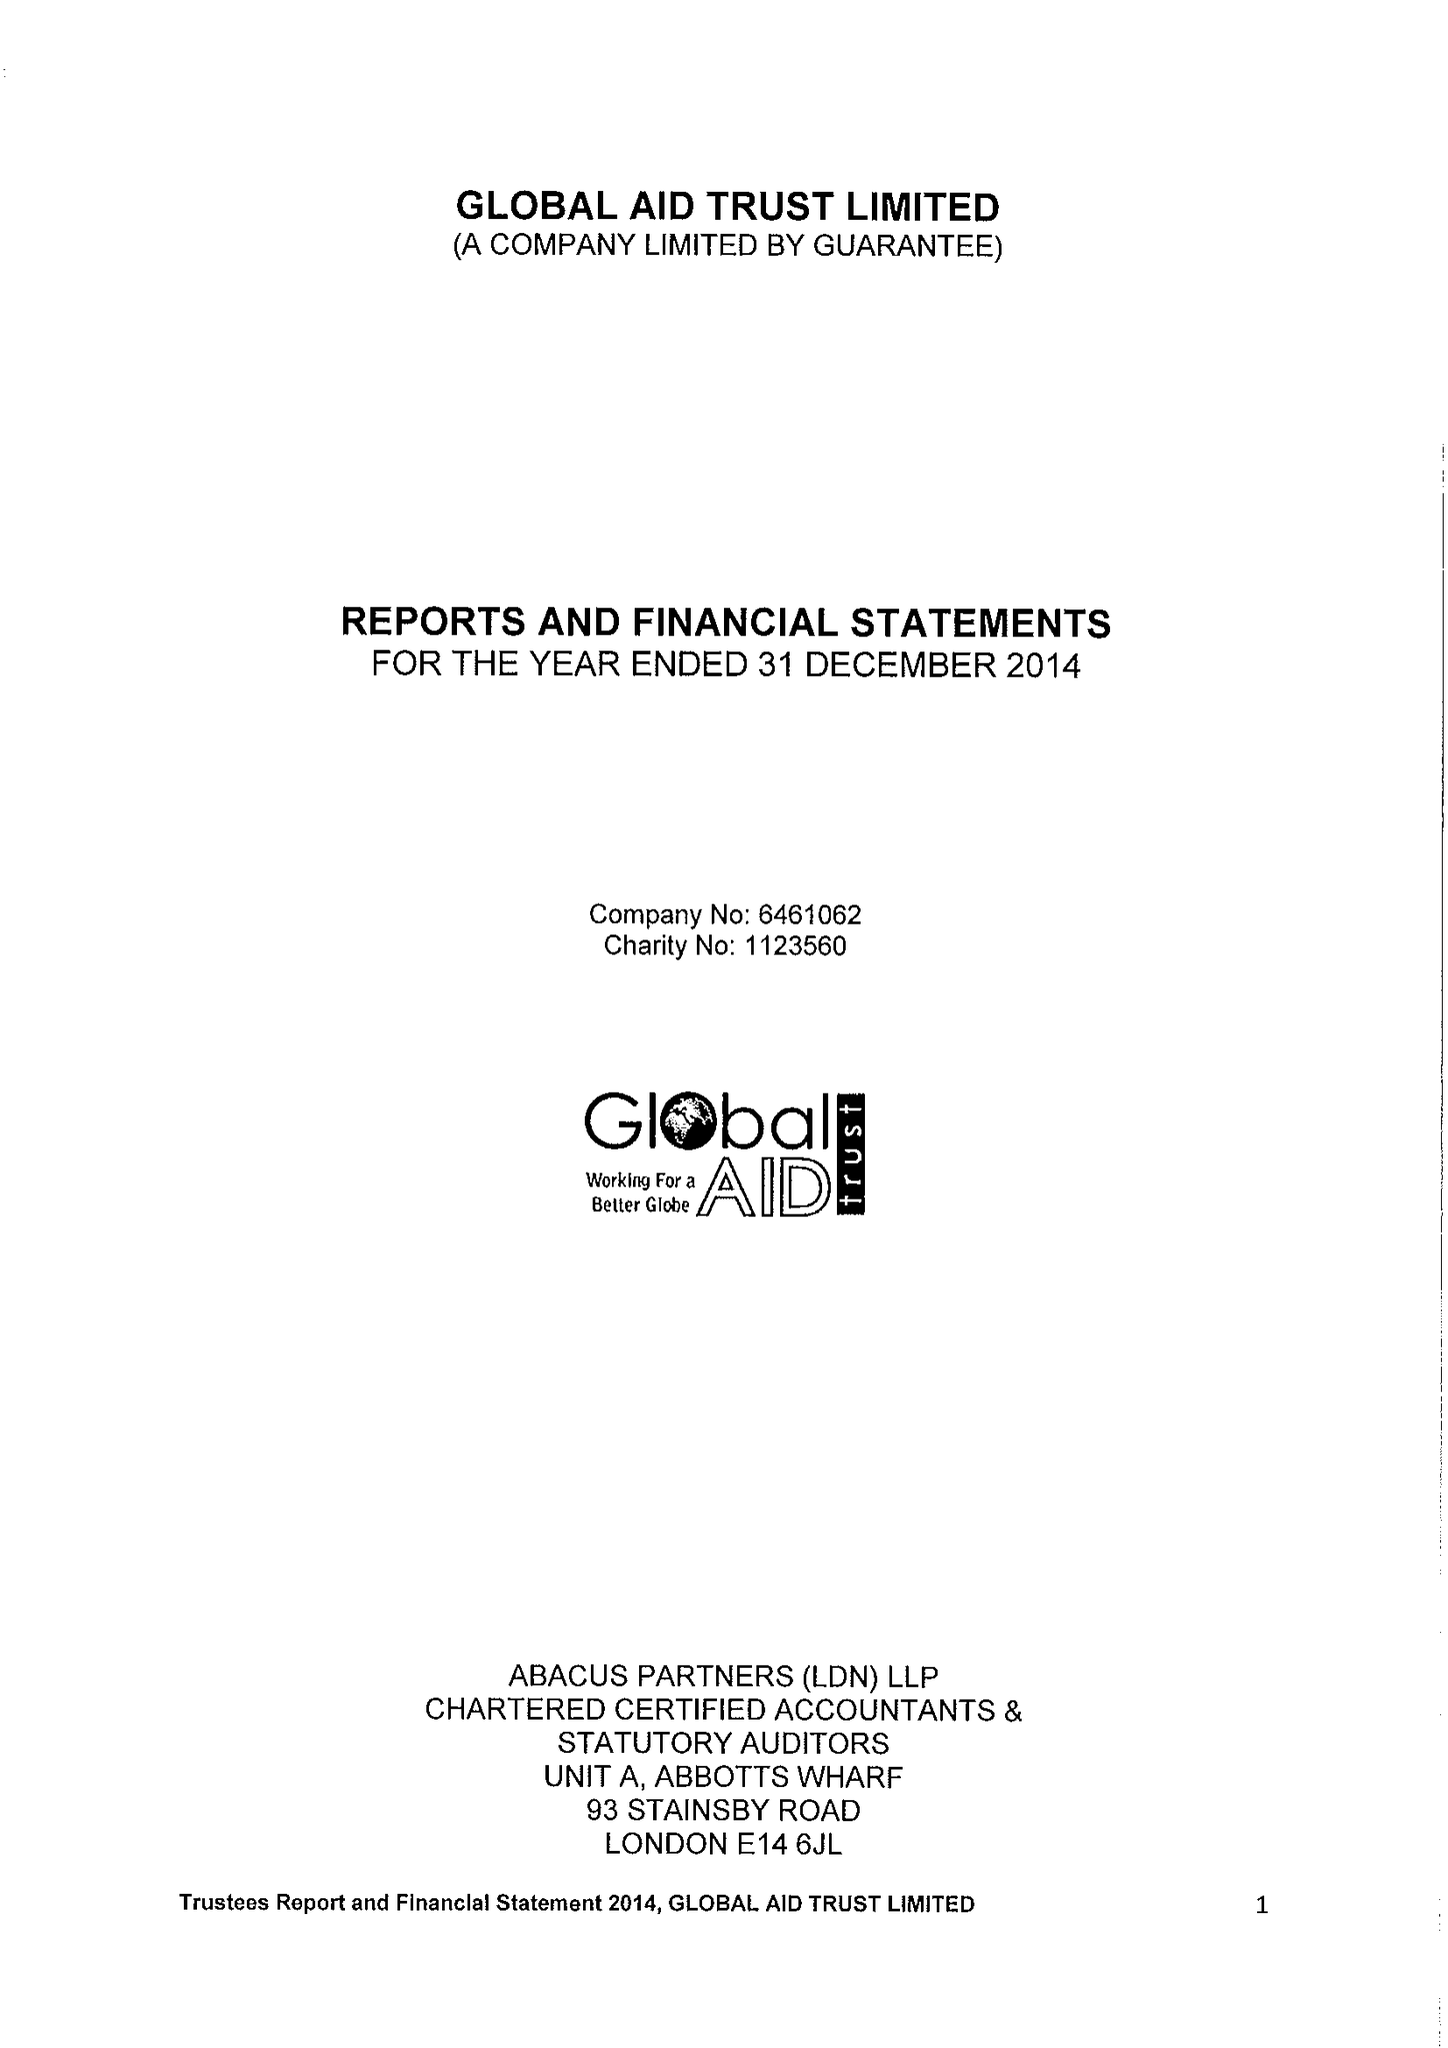What is the value for the charity_number?
Answer the question using a single word or phrase. 1123560 